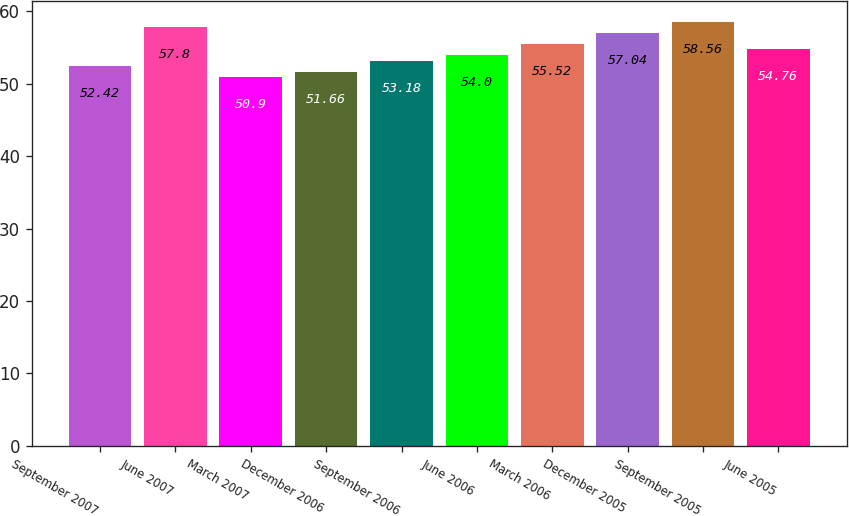Convert chart to OTSL. <chart><loc_0><loc_0><loc_500><loc_500><bar_chart><fcel>September 2007<fcel>June 2007<fcel>March 2007<fcel>December 2006<fcel>September 2006<fcel>June 2006<fcel>March 2006<fcel>December 2005<fcel>September 2005<fcel>June 2005<nl><fcel>52.42<fcel>57.8<fcel>50.9<fcel>51.66<fcel>53.18<fcel>54<fcel>55.52<fcel>57.04<fcel>58.56<fcel>54.76<nl></chart> 